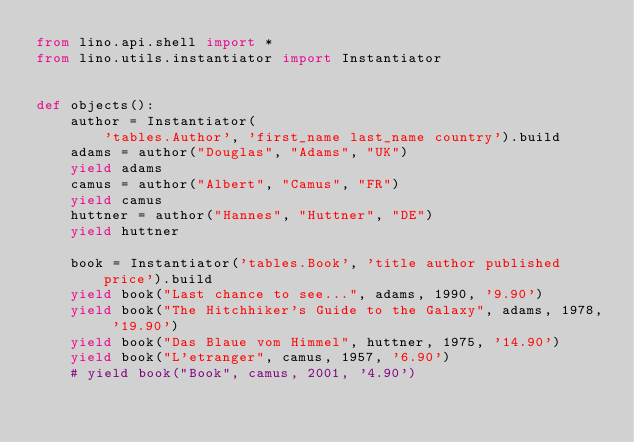<code> <loc_0><loc_0><loc_500><loc_500><_Python_>from lino.api.shell import *
from lino.utils.instantiator import Instantiator


def objects():
    author = Instantiator(
        'tables.Author', 'first_name last_name country').build
    adams = author("Douglas", "Adams", "UK")
    yield adams
    camus = author("Albert", "Camus", "FR")
    yield camus
    huttner = author("Hannes", "Huttner", "DE")
    yield huttner

    book = Instantiator('tables.Book', 'title author published price').build
    yield book("Last chance to see...", adams, 1990, '9.90')
    yield book("The Hitchhiker's Guide to the Galaxy", adams, 1978, '19.90')
    yield book("Das Blaue vom Himmel", huttner, 1975, '14.90')
    yield book("L'etranger", camus, 1957, '6.90')
    # yield book("Book", camus, 2001, '4.90')

</code> 